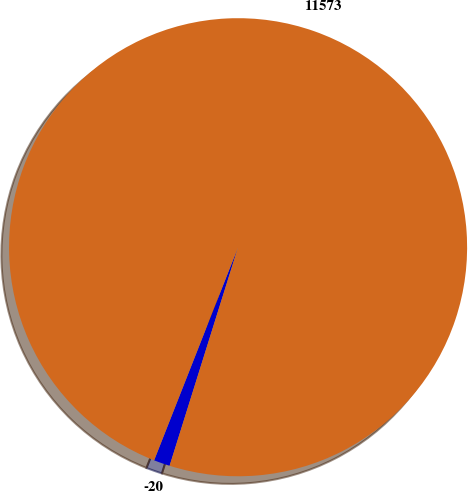Convert chart to OTSL. <chart><loc_0><loc_0><loc_500><loc_500><pie_chart><fcel>-20<fcel>11573<nl><fcel>1.14%<fcel>98.86%<nl></chart> 